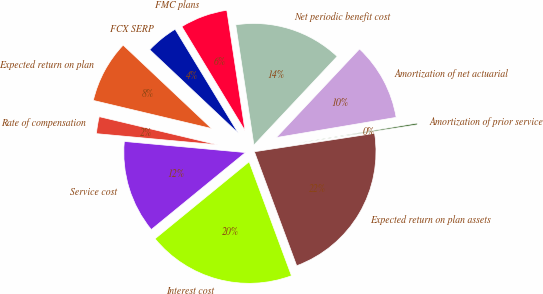<chart> <loc_0><loc_0><loc_500><loc_500><pie_chart><fcel>FMC plans<fcel>FCX SERP<fcel>Expected return on plan<fcel>Rate of compensation<fcel>Service cost<fcel>Interest cost<fcel>Expected return on plan assets<fcel>Amortization of prior service<fcel>Amortization of net actuarial<fcel>Net periodic benefit cost<nl><fcel>6.3%<fcel>4.28%<fcel>8.32%<fcel>2.26%<fcel>12.37%<fcel>19.74%<fcel>21.76%<fcel>0.24%<fcel>10.34%<fcel>14.39%<nl></chart> 